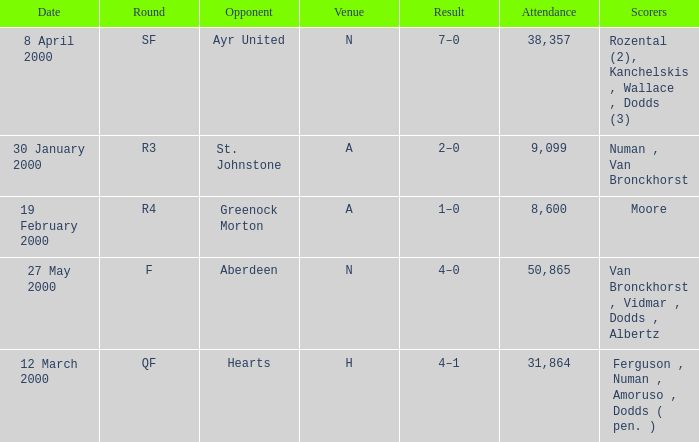Who was on 12 March 2000? Ferguson , Numan , Amoruso , Dodds ( pen. ). 